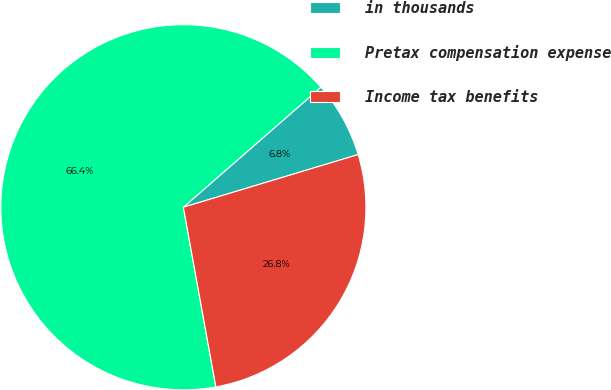<chart> <loc_0><loc_0><loc_500><loc_500><pie_chart><fcel>in thousands<fcel>Pretax compensation expense<fcel>Income tax benefits<nl><fcel>6.76%<fcel>66.43%<fcel>26.81%<nl></chart> 